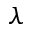Convert formula to latex. <formula><loc_0><loc_0><loc_500><loc_500>\lambda</formula> 